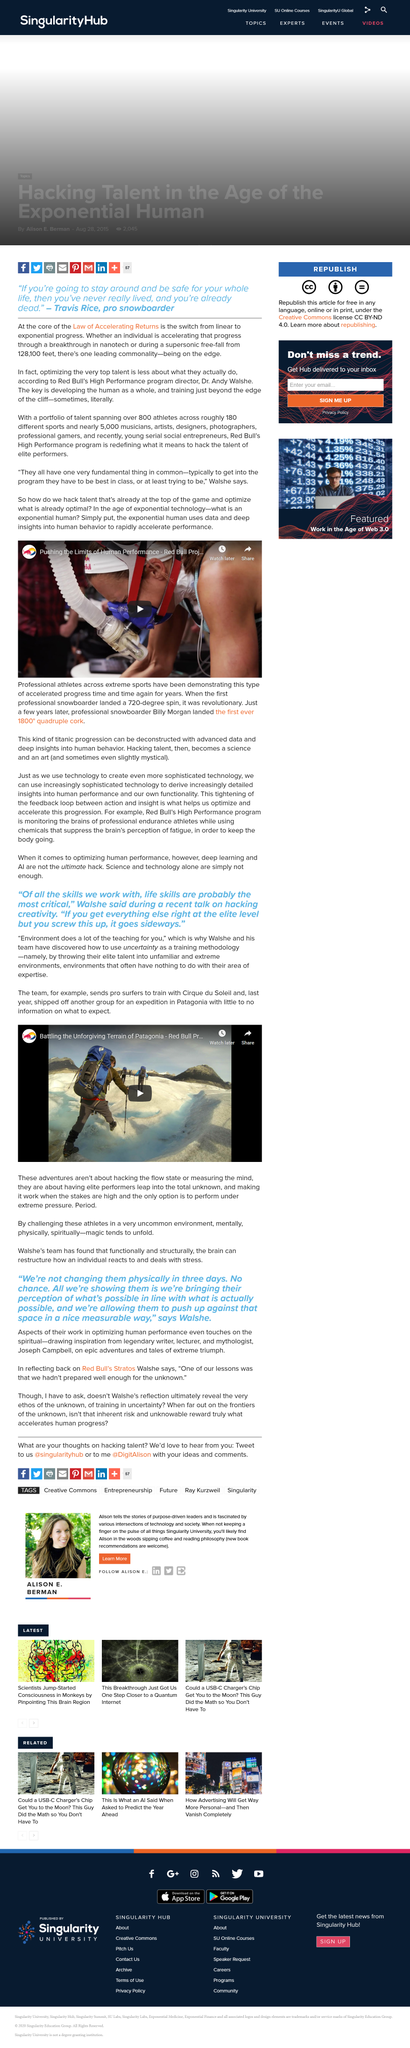Give some essential details in this illustration. There were approximately 5,000 musicians in the high performance program. The video is shareable. The answer is yes. Walshe's team discovered that the brain can restructure an individual's response to and coping with stress, both functionally and structurally. Dr. Andy Walshe is Red Bull's High Performance Program Director and plays a crucial role in the development and implementation of the company's performance enhancement strategies. The title of the video is "Battling the Unforgiving Terrain of Patagonia," which showcases the challenging and rugged landscape of Patagonia and the perseverance and skill required to navigate it. 